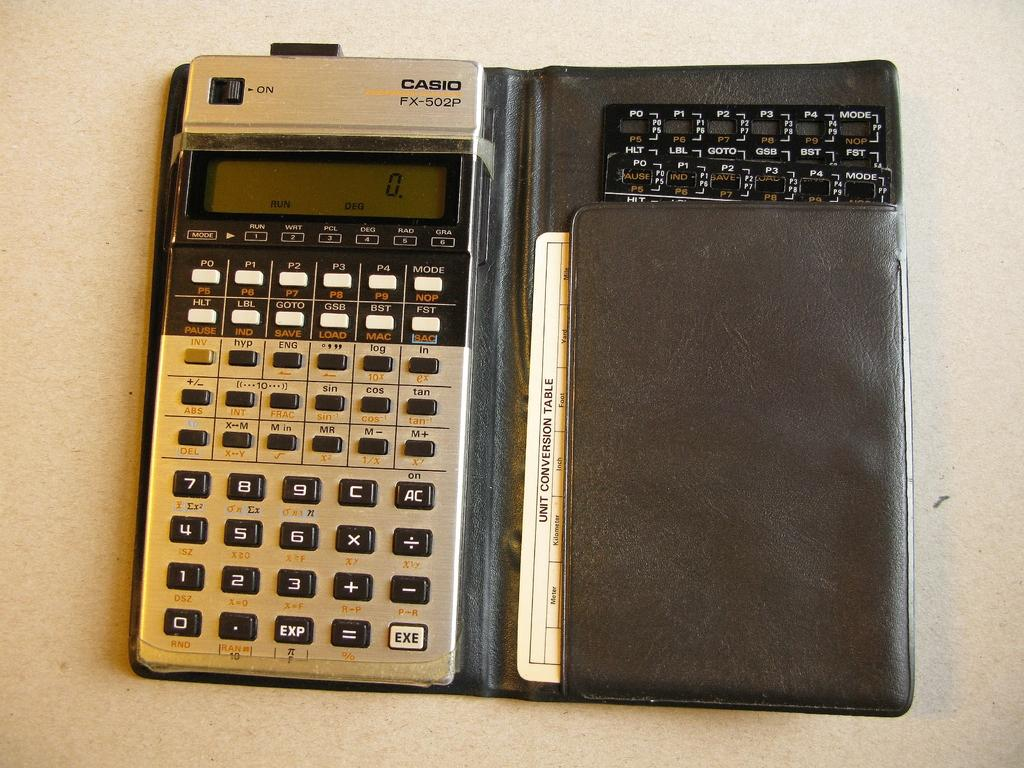Provide a one-sentence caption for the provided image. The Casio FX-502P calculator is displaying 0 on the screen. 